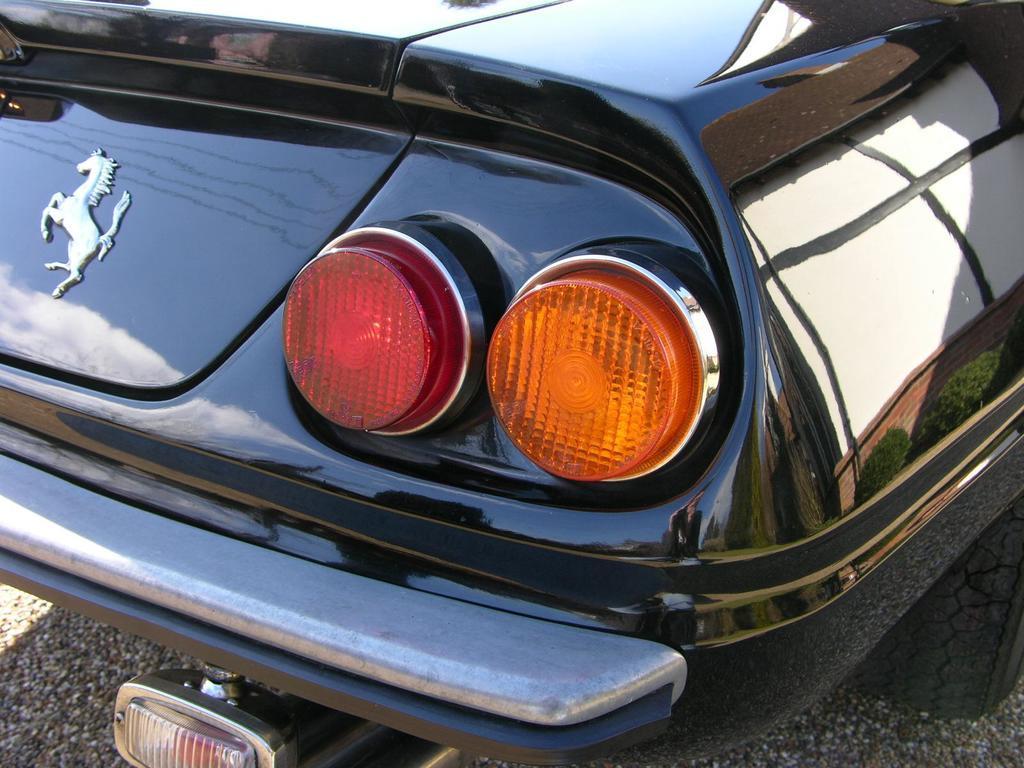Describe this image in one or two sentences. In this image we can see a motor vehicle on the road. 